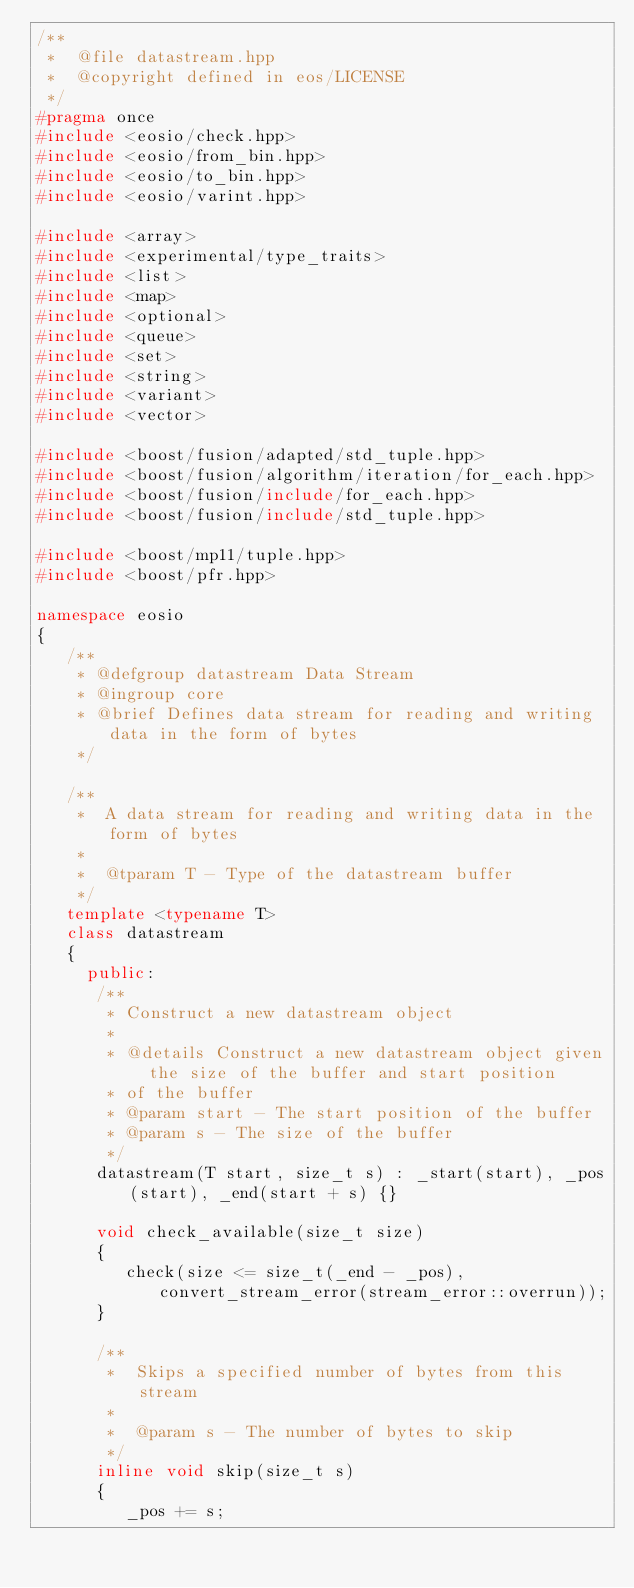<code> <loc_0><loc_0><loc_500><loc_500><_C++_>/**
 *  @file datastream.hpp
 *  @copyright defined in eos/LICENSE
 */
#pragma once
#include <eosio/check.hpp>
#include <eosio/from_bin.hpp>
#include <eosio/to_bin.hpp>
#include <eosio/varint.hpp>

#include <array>
#include <experimental/type_traits>
#include <list>
#include <map>
#include <optional>
#include <queue>
#include <set>
#include <string>
#include <variant>
#include <vector>

#include <boost/fusion/adapted/std_tuple.hpp>
#include <boost/fusion/algorithm/iteration/for_each.hpp>
#include <boost/fusion/include/for_each.hpp>
#include <boost/fusion/include/std_tuple.hpp>

#include <boost/mp11/tuple.hpp>
#include <boost/pfr.hpp>

namespace eosio
{
   /**
    * @defgroup datastream Data Stream
    * @ingroup core
    * @brief Defines data stream for reading and writing data in the form of bytes
    */

   /**
    *  A data stream for reading and writing data in the form of bytes
    *
    *  @tparam T - Type of the datastream buffer
    */
   template <typename T>
   class datastream
   {
     public:
      /**
       * Construct a new datastream object
       *
       * @details Construct a new datastream object given the size of the buffer and start position
       * of the buffer
       * @param start - The start position of the buffer
       * @param s - The size of the buffer
       */
      datastream(T start, size_t s) : _start(start), _pos(start), _end(start + s) {}

      void check_available(size_t size)
      {
         check(size <= size_t(_end - _pos), convert_stream_error(stream_error::overrun));
      }

      /**
       *  Skips a specified number of bytes from this stream
       *
       *  @param s - The number of bytes to skip
       */
      inline void skip(size_t s)
      {
         _pos += s;</code> 